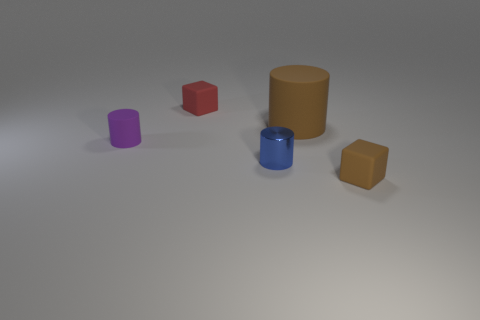What number of cubes have the same color as the big rubber cylinder?
Keep it short and to the point. 1. The tiny brown thing has what shape?
Your response must be concise. Cube. What is the color of the object that is both behind the tiny purple matte cylinder and on the right side of the tiny red rubber cube?
Give a very brief answer. Brown. What is the blue cylinder made of?
Offer a very short reply. Metal. There is a tiny matte object that is behind the large rubber cylinder; what is its shape?
Provide a short and direct response. Cube. There is another rubber block that is the same size as the red rubber cube; what is its color?
Make the answer very short. Brown. Is the small block on the left side of the blue metallic thing made of the same material as the small purple cylinder?
Your answer should be very brief. Yes. There is a object that is behind the tiny blue metal object and right of the red thing; how big is it?
Keep it short and to the point. Large. There is a brown matte object that is to the right of the big brown matte cylinder; what is its size?
Offer a terse response. Small. The small rubber thing that is the same color as the large rubber cylinder is what shape?
Offer a terse response. Cube. 